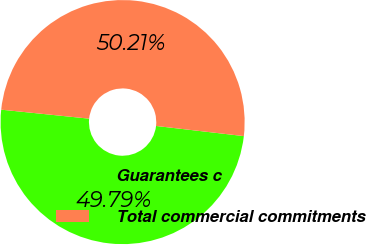Convert chart to OTSL. <chart><loc_0><loc_0><loc_500><loc_500><pie_chart><fcel>Guarantees c<fcel>Total commercial commitments<nl><fcel>49.79%<fcel>50.21%<nl></chart> 